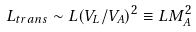<formula> <loc_0><loc_0><loc_500><loc_500>L _ { t r a n s } \sim L ( V _ { L } / V _ { A } ) ^ { 2 } \equiv L M _ { A } ^ { 2 }</formula> 